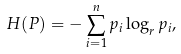<formula> <loc_0><loc_0><loc_500><loc_500>H ( P ) = - \sum _ { i = 1 } ^ { n } p _ { i } \log _ { r } p _ { i } ,</formula> 